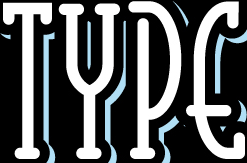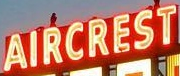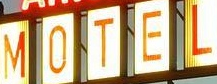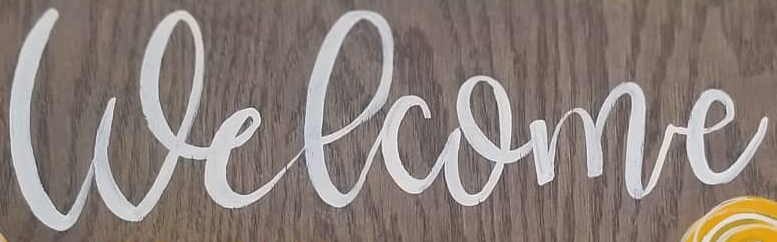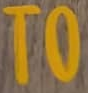What words can you see in these images in sequence, separated by a semicolon? TYPE; AIRCREST; MOTEL; Welcome; TO 